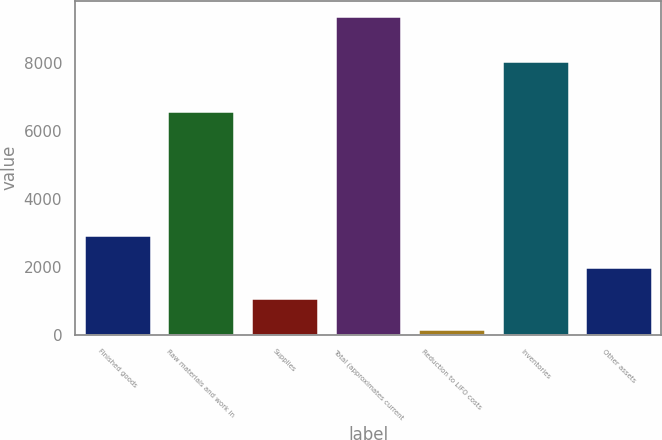Convert chart to OTSL. <chart><loc_0><loc_0><loc_500><loc_500><bar_chart><fcel>Finished goods<fcel>Raw materials and work in<fcel>Supplies<fcel>Total (approximates current<fcel>Reduction to LIFO costs<fcel>Inventories<fcel>Other assets<nl><fcel>2928.5<fcel>6583<fcel>1087.5<fcel>9372<fcel>167<fcel>8048<fcel>2008<nl></chart> 